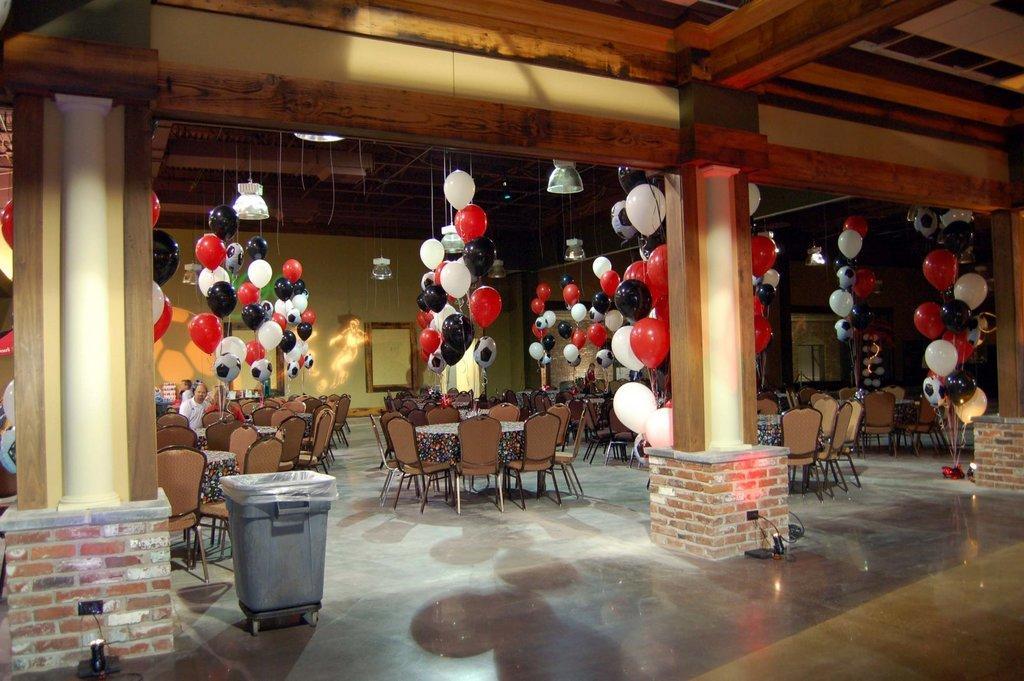Could you give a brief overview of what you see in this image? It looks like this image is clicked in a restaurant. There are balloon tied to the roof and hanged. There are many chairs and tables. To the left, there is a pillar. Beside that there is a dustbin. At the bottom, there is floor. 